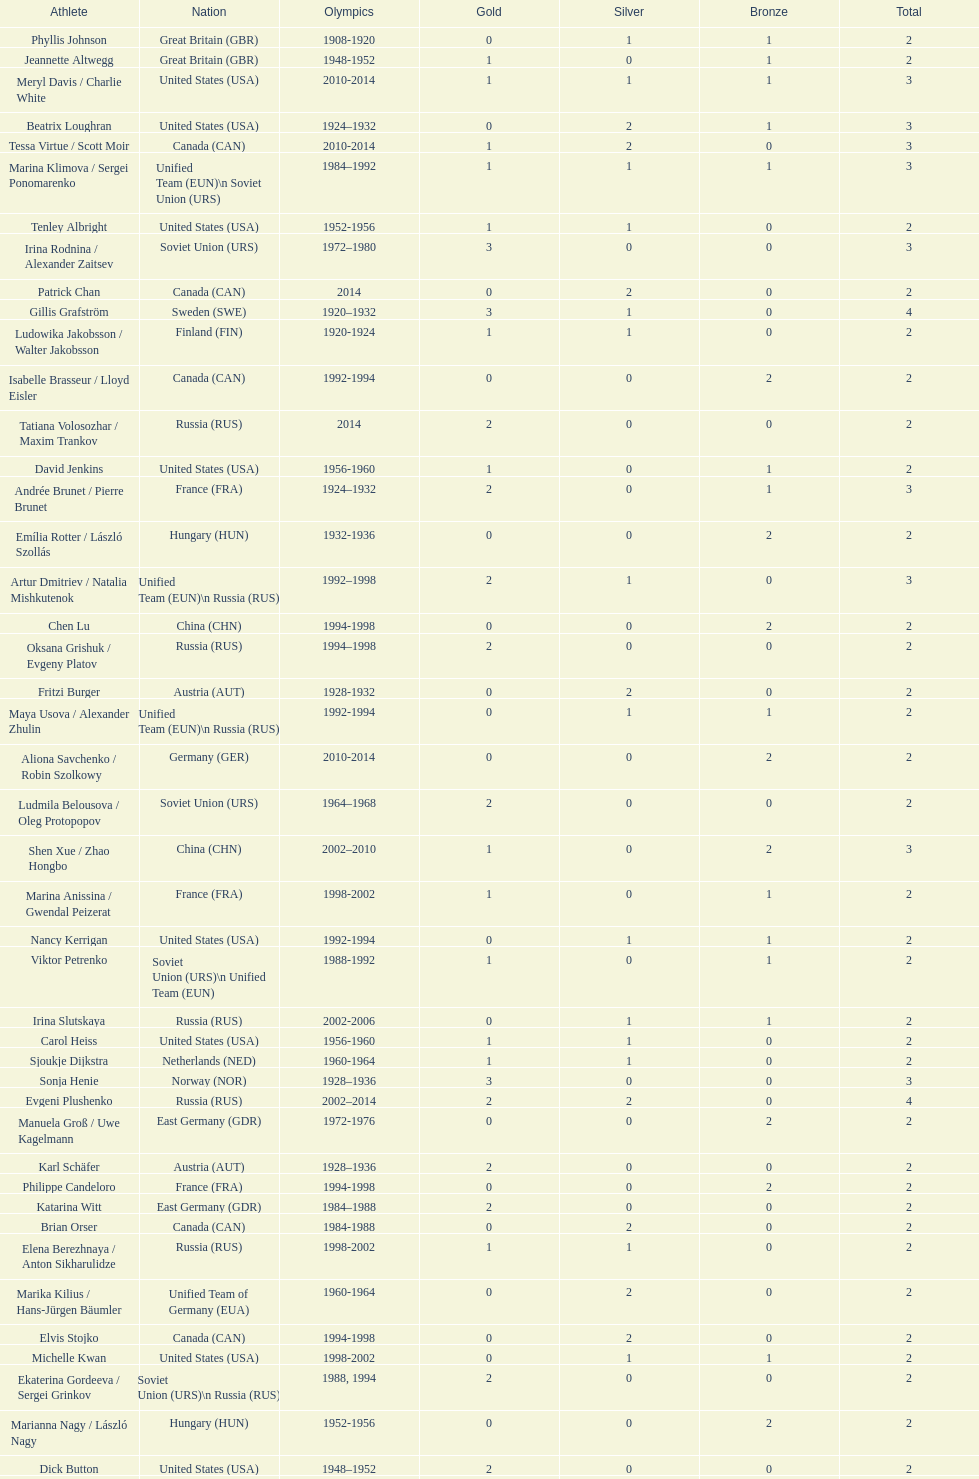Which nation was the first to win three gold medals for olympic figure skating? Sweden. 